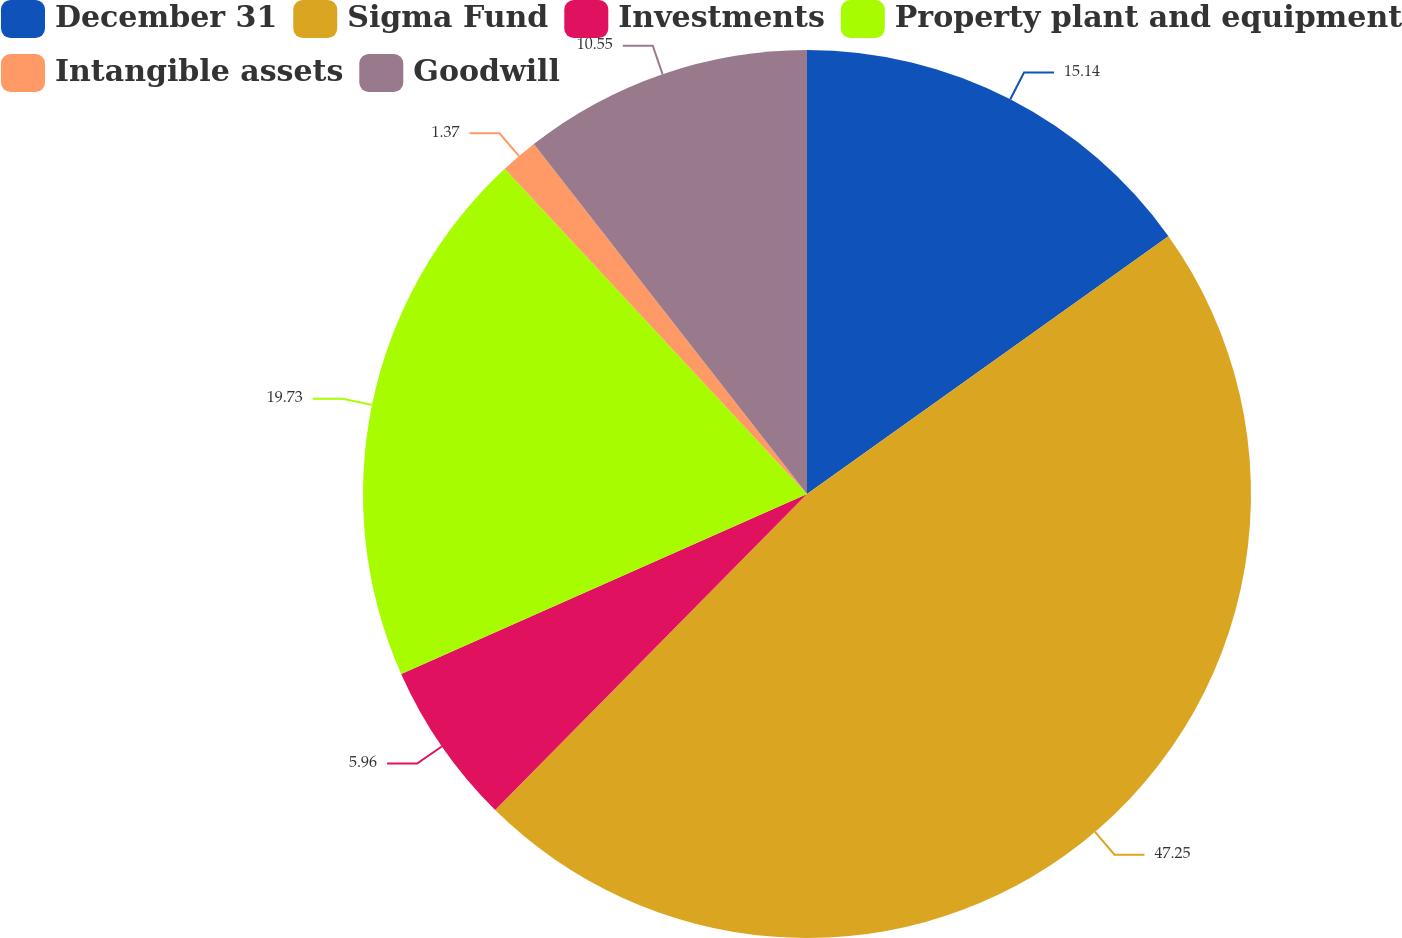Convert chart. <chart><loc_0><loc_0><loc_500><loc_500><pie_chart><fcel>December 31<fcel>Sigma Fund<fcel>Investments<fcel>Property plant and equipment<fcel>Intangible assets<fcel>Goodwill<nl><fcel>15.14%<fcel>47.26%<fcel>5.96%<fcel>19.73%<fcel>1.37%<fcel>10.55%<nl></chart> 